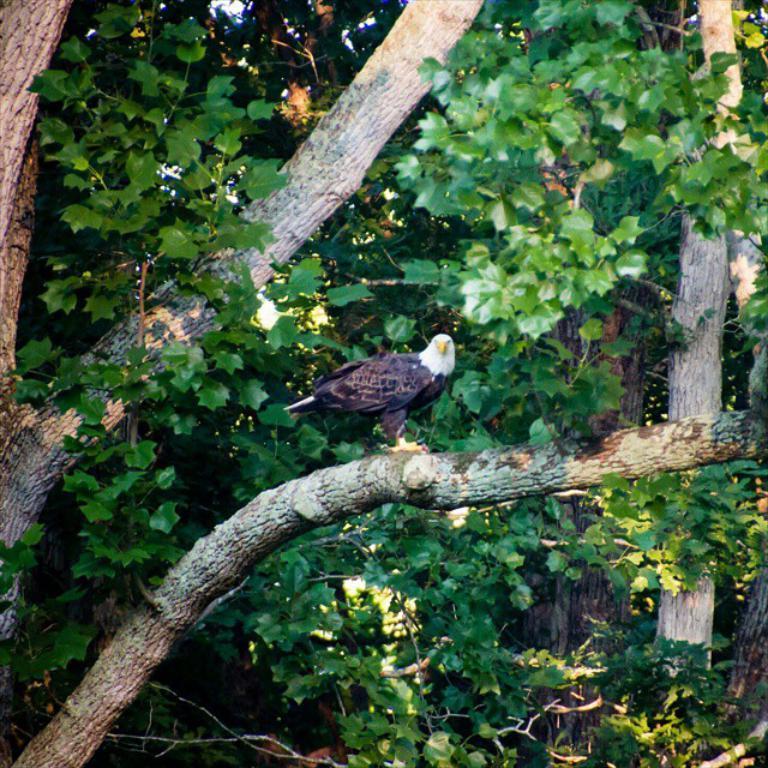Please provide a concise description of this image. In this image I can see a bird which is brown, white and yellow in color is on a tree branch. I can see few leaves of a tree which are green in color and few flowers which are white in color. 